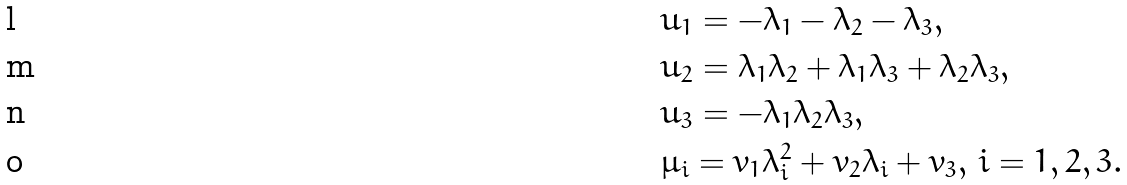Convert formula to latex. <formula><loc_0><loc_0><loc_500><loc_500>& u _ { 1 } = - \lambda _ { 1 } - \lambda _ { 2 } - \lambda _ { 3 } , \\ & u _ { 2 } = \lambda _ { 1 } \lambda _ { 2 } + \lambda _ { 1 } \lambda _ { 3 } + \lambda _ { 2 } \lambda _ { 3 } , \\ & u _ { 3 } = - \lambda _ { 1 } \lambda _ { 2 } \lambda _ { 3 } , \\ & \mu _ { i } = v _ { 1 } \lambda _ { i } ^ { 2 } + v _ { 2 } \lambda _ { i } + v _ { 3 } , \, i = 1 , 2 , 3 .</formula> 